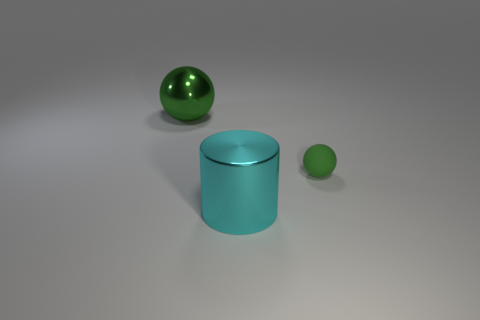What number of objects are on the left side of the large cyan cylinder?
Your response must be concise. 1. Are there more small green spheres that are behind the green metal ball than tiny balls?
Make the answer very short. No. What is the shape of the cyan object that is made of the same material as the large green ball?
Your answer should be compact. Cylinder. There is a metal object that is in front of the green object that is on the left side of the small rubber ball; what is its color?
Your answer should be compact. Cyan. Is the green rubber object the same shape as the big cyan shiny object?
Ensure brevity in your answer.  No. There is a big thing that is the same shape as the tiny green object; what is it made of?
Provide a short and direct response. Metal. Is there a small matte thing in front of the green matte ball on the right side of the large metal object that is in front of the big ball?
Give a very brief answer. No. There is a green metal object; is it the same shape as the big metal object in front of the rubber ball?
Offer a terse response. No. Is there any other thing of the same color as the small ball?
Your response must be concise. Yes. There is a large thing that is left of the big cyan cylinder; does it have the same color as the big shiny thing that is in front of the tiny green matte thing?
Offer a very short reply. No. 